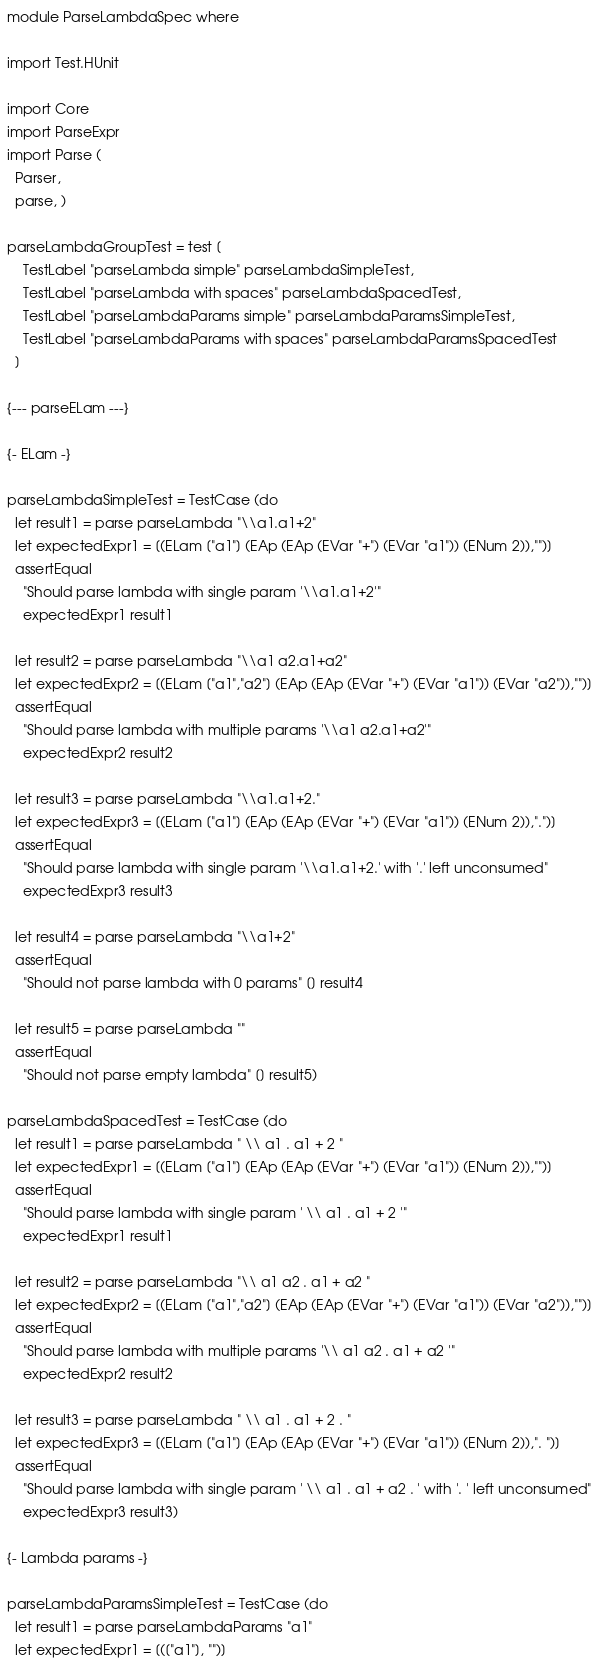<code> <loc_0><loc_0><loc_500><loc_500><_Haskell_>module ParseLambdaSpec where

import Test.HUnit

import Core
import ParseExpr
import Parse (
  Parser,
  parse, )

parseLambdaGroupTest = test [
    TestLabel "parseLambda simple" parseLambdaSimpleTest,
    TestLabel "parseLambda with spaces" parseLambdaSpacedTest,
    TestLabel "parseLambdaParams simple" parseLambdaParamsSimpleTest,
    TestLabel "parseLambdaParams with spaces" parseLambdaParamsSpacedTest
  ]

{--- parseELam ---}

{- ELam -}

parseLambdaSimpleTest = TestCase (do
  let result1 = parse parseLambda "\\a1.a1+2"
  let expectedExpr1 = [(ELam ["a1"] (EAp (EAp (EVar "+") (EVar "a1")) (ENum 2)),"")]
  assertEqual
    "Should parse lambda with single param '\\a1.a1+2'"
    expectedExpr1 result1

  let result2 = parse parseLambda "\\a1 a2.a1+a2"
  let expectedExpr2 = [(ELam ["a1","a2"] (EAp (EAp (EVar "+") (EVar "a1")) (EVar "a2")),"")]
  assertEqual
    "Should parse lambda with multiple params '\\a1 a2.a1+a2'"
    expectedExpr2 result2

  let result3 = parse parseLambda "\\a1.a1+2."
  let expectedExpr3 = [(ELam ["a1"] (EAp (EAp (EVar "+") (EVar "a1")) (ENum 2)),".")]
  assertEqual
    "Should parse lambda with single param '\\a1.a1+2.' with '.' left unconsumed"
    expectedExpr3 result3

  let result4 = parse parseLambda "\\a1+2"
  assertEqual 
    "Should not parse lambda with 0 params" [] result4

  let result5 = parse parseLambda ""
  assertEqual
    "Should not parse empty lambda" [] result5)

parseLambdaSpacedTest = TestCase (do
  let result1 = parse parseLambda " \\ a1 . a1 + 2 "
  let expectedExpr1 = [(ELam ["a1"] (EAp (EAp (EVar "+") (EVar "a1")) (ENum 2)),"")]
  assertEqual
    "Should parse lambda with single param ' \\ a1 . a1 + 2 '"
    expectedExpr1 result1

  let result2 = parse parseLambda "\\ a1 a2 . a1 + a2 "
  let expectedExpr2 = [(ELam ["a1","a2"] (EAp (EAp (EVar "+") (EVar "a1")) (EVar "a2")),"")]
  assertEqual
    "Should parse lambda with multiple params '\\ a1 a2 . a1 + a2 '"
    expectedExpr2 result2

  let result3 = parse parseLambda " \\ a1 . a1 + 2 . "
  let expectedExpr3 = [(ELam ["a1"] (EAp (EAp (EVar "+") (EVar "a1")) (ENum 2)),". ")]
  assertEqual 
    "Should parse lambda with single param ' \\ a1 . a1 + a2 . ' with '. ' left unconsumed"
    expectedExpr3 result3)

{- Lambda params -}

parseLambdaParamsSimpleTest = TestCase (do
  let result1 = parse parseLambdaParams "a1"
  let expectedExpr1 = [(["a1"], "")]</code> 